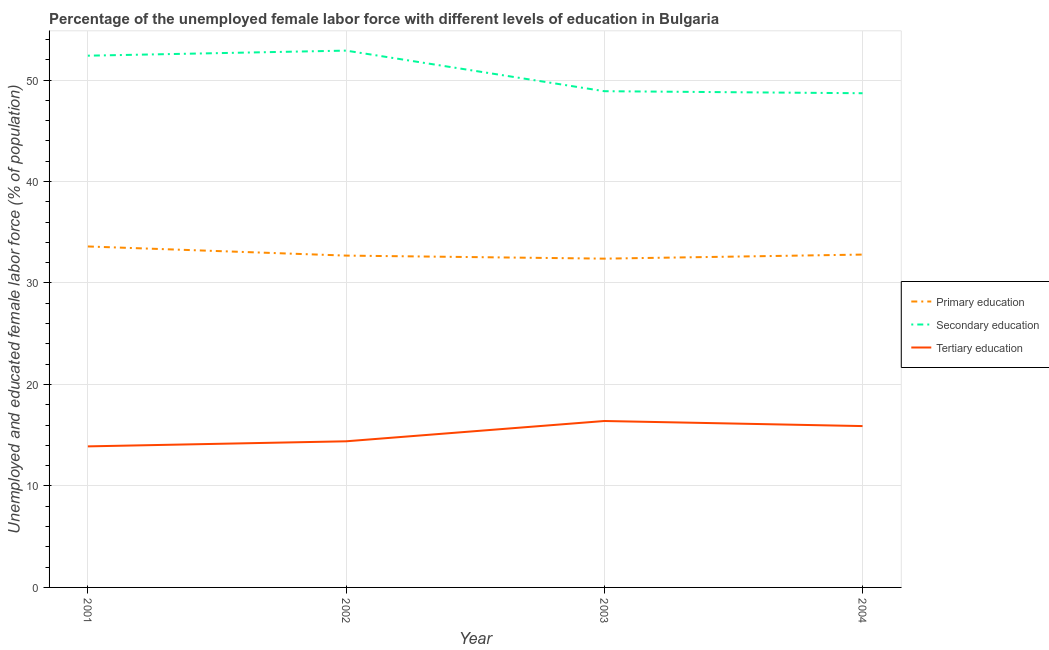How many different coloured lines are there?
Ensure brevity in your answer.  3. What is the percentage of female labor force who received tertiary education in 2002?
Make the answer very short. 14.4. Across all years, what is the maximum percentage of female labor force who received primary education?
Your answer should be very brief. 33.6. Across all years, what is the minimum percentage of female labor force who received secondary education?
Your answer should be compact. 48.7. In which year was the percentage of female labor force who received tertiary education maximum?
Offer a terse response. 2003. In which year was the percentage of female labor force who received tertiary education minimum?
Provide a succinct answer. 2001. What is the total percentage of female labor force who received secondary education in the graph?
Give a very brief answer. 202.9. What is the difference between the percentage of female labor force who received primary education in 2002 and that in 2003?
Provide a short and direct response. 0.3. What is the difference between the percentage of female labor force who received secondary education in 2001 and the percentage of female labor force who received primary education in 2002?
Offer a terse response. 19.7. What is the average percentage of female labor force who received tertiary education per year?
Keep it short and to the point. 15.15. In the year 2004, what is the difference between the percentage of female labor force who received secondary education and percentage of female labor force who received tertiary education?
Provide a succinct answer. 32.8. What is the ratio of the percentage of female labor force who received primary education in 2001 to that in 2003?
Keep it short and to the point. 1.04. What is the difference between the highest and the second highest percentage of female labor force who received secondary education?
Offer a very short reply. 0.5. What is the difference between the highest and the lowest percentage of female labor force who received secondary education?
Provide a short and direct response. 4.2. In how many years, is the percentage of female labor force who received primary education greater than the average percentage of female labor force who received primary education taken over all years?
Give a very brief answer. 1. Is the sum of the percentage of female labor force who received primary education in 2001 and 2004 greater than the maximum percentage of female labor force who received secondary education across all years?
Provide a succinct answer. Yes. Is it the case that in every year, the sum of the percentage of female labor force who received primary education and percentage of female labor force who received secondary education is greater than the percentage of female labor force who received tertiary education?
Provide a short and direct response. Yes. Does the percentage of female labor force who received secondary education monotonically increase over the years?
Provide a short and direct response. No. Is the percentage of female labor force who received tertiary education strictly less than the percentage of female labor force who received secondary education over the years?
Provide a short and direct response. Yes. How many lines are there?
Keep it short and to the point. 3. What is the difference between two consecutive major ticks on the Y-axis?
Provide a succinct answer. 10. Are the values on the major ticks of Y-axis written in scientific E-notation?
Provide a succinct answer. No. Does the graph contain grids?
Your response must be concise. Yes. Where does the legend appear in the graph?
Your answer should be very brief. Center right. What is the title of the graph?
Provide a short and direct response. Percentage of the unemployed female labor force with different levels of education in Bulgaria. What is the label or title of the Y-axis?
Make the answer very short. Unemployed and educated female labor force (% of population). What is the Unemployed and educated female labor force (% of population) in Primary education in 2001?
Offer a terse response. 33.6. What is the Unemployed and educated female labor force (% of population) of Secondary education in 2001?
Provide a short and direct response. 52.4. What is the Unemployed and educated female labor force (% of population) of Tertiary education in 2001?
Offer a terse response. 13.9. What is the Unemployed and educated female labor force (% of population) in Primary education in 2002?
Offer a very short reply. 32.7. What is the Unemployed and educated female labor force (% of population) of Secondary education in 2002?
Provide a succinct answer. 52.9. What is the Unemployed and educated female labor force (% of population) of Tertiary education in 2002?
Make the answer very short. 14.4. What is the Unemployed and educated female labor force (% of population) of Primary education in 2003?
Ensure brevity in your answer.  32.4. What is the Unemployed and educated female labor force (% of population) of Secondary education in 2003?
Your answer should be very brief. 48.9. What is the Unemployed and educated female labor force (% of population) in Tertiary education in 2003?
Your answer should be compact. 16.4. What is the Unemployed and educated female labor force (% of population) in Primary education in 2004?
Offer a very short reply. 32.8. What is the Unemployed and educated female labor force (% of population) in Secondary education in 2004?
Offer a terse response. 48.7. What is the Unemployed and educated female labor force (% of population) in Tertiary education in 2004?
Give a very brief answer. 15.9. Across all years, what is the maximum Unemployed and educated female labor force (% of population) in Primary education?
Offer a terse response. 33.6. Across all years, what is the maximum Unemployed and educated female labor force (% of population) in Secondary education?
Provide a succinct answer. 52.9. Across all years, what is the maximum Unemployed and educated female labor force (% of population) of Tertiary education?
Keep it short and to the point. 16.4. Across all years, what is the minimum Unemployed and educated female labor force (% of population) of Primary education?
Keep it short and to the point. 32.4. Across all years, what is the minimum Unemployed and educated female labor force (% of population) in Secondary education?
Offer a terse response. 48.7. Across all years, what is the minimum Unemployed and educated female labor force (% of population) in Tertiary education?
Make the answer very short. 13.9. What is the total Unemployed and educated female labor force (% of population) in Primary education in the graph?
Ensure brevity in your answer.  131.5. What is the total Unemployed and educated female labor force (% of population) of Secondary education in the graph?
Provide a succinct answer. 202.9. What is the total Unemployed and educated female labor force (% of population) of Tertiary education in the graph?
Ensure brevity in your answer.  60.6. What is the difference between the Unemployed and educated female labor force (% of population) in Secondary education in 2001 and that in 2002?
Your answer should be compact. -0.5. What is the difference between the Unemployed and educated female labor force (% of population) of Tertiary education in 2001 and that in 2002?
Offer a very short reply. -0.5. What is the difference between the Unemployed and educated female labor force (% of population) in Primary education in 2001 and that in 2003?
Your answer should be compact. 1.2. What is the difference between the Unemployed and educated female labor force (% of population) of Primary education in 2002 and that in 2004?
Keep it short and to the point. -0.1. What is the difference between the Unemployed and educated female labor force (% of population) in Tertiary education in 2003 and that in 2004?
Offer a terse response. 0.5. What is the difference between the Unemployed and educated female labor force (% of population) in Primary education in 2001 and the Unemployed and educated female labor force (% of population) in Secondary education in 2002?
Make the answer very short. -19.3. What is the difference between the Unemployed and educated female labor force (% of population) in Secondary education in 2001 and the Unemployed and educated female labor force (% of population) in Tertiary education in 2002?
Offer a terse response. 38. What is the difference between the Unemployed and educated female labor force (% of population) of Primary education in 2001 and the Unemployed and educated female labor force (% of population) of Secondary education in 2003?
Provide a succinct answer. -15.3. What is the difference between the Unemployed and educated female labor force (% of population) of Primary education in 2001 and the Unemployed and educated female labor force (% of population) of Secondary education in 2004?
Make the answer very short. -15.1. What is the difference between the Unemployed and educated female labor force (% of population) of Primary education in 2001 and the Unemployed and educated female labor force (% of population) of Tertiary education in 2004?
Offer a very short reply. 17.7. What is the difference between the Unemployed and educated female labor force (% of population) of Secondary education in 2001 and the Unemployed and educated female labor force (% of population) of Tertiary education in 2004?
Offer a very short reply. 36.5. What is the difference between the Unemployed and educated female labor force (% of population) in Primary education in 2002 and the Unemployed and educated female labor force (% of population) in Secondary education in 2003?
Keep it short and to the point. -16.2. What is the difference between the Unemployed and educated female labor force (% of population) in Primary education in 2002 and the Unemployed and educated female labor force (% of population) in Tertiary education in 2003?
Offer a terse response. 16.3. What is the difference between the Unemployed and educated female labor force (% of population) in Secondary education in 2002 and the Unemployed and educated female labor force (% of population) in Tertiary education in 2003?
Provide a short and direct response. 36.5. What is the difference between the Unemployed and educated female labor force (% of population) in Primary education in 2003 and the Unemployed and educated female labor force (% of population) in Secondary education in 2004?
Ensure brevity in your answer.  -16.3. What is the difference between the Unemployed and educated female labor force (% of population) of Secondary education in 2003 and the Unemployed and educated female labor force (% of population) of Tertiary education in 2004?
Your response must be concise. 33. What is the average Unemployed and educated female labor force (% of population) in Primary education per year?
Ensure brevity in your answer.  32.88. What is the average Unemployed and educated female labor force (% of population) in Secondary education per year?
Offer a terse response. 50.73. What is the average Unemployed and educated female labor force (% of population) in Tertiary education per year?
Offer a very short reply. 15.15. In the year 2001, what is the difference between the Unemployed and educated female labor force (% of population) in Primary education and Unemployed and educated female labor force (% of population) in Secondary education?
Keep it short and to the point. -18.8. In the year 2001, what is the difference between the Unemployed and educated female labor force (% of population) of Secondary education and Unemployed and educated female labor force (% of population) of Tertiary education?
Provide a short and direct response. 38.5. In the year 2002, what is the difference between the Unemployed and educated female labor force (% of population) in Primary education and Unemployed and educated female labor force (% of population) in Secondary education?
Offer a terse response. -20.2. In the year 2002, what is the difference between the Unemployed and educated female labor force (% of population) in Primary education and Unemployed and educated female labor force (% of population) in Tertiary education?
Provide a short and direct response. 18.3. In the year 2002, what is the difference between the Unemployed and educated female labor force (% of population) of Secondary education and Unemployed and educated female labor force (% of population) of Tertiary education?
Offer a very short reply. 38.5. In the year 2003, what is the difference between the Unemployed and educated female labor force (% of population) of Primary education and Unemployed and educated female labor force (% of population) of Secondary education?
Offer a very short reply. -16.5. In the year 2003, what is the difference between the Unemployed and educated female labor force (% of population) in Primary education and Unemployed and educated female labor force (% of population) in Tertiary education?
Your answer should be very brief. 16. In the year 2003, what is the difference between the Unemployed and educated female labor force (% of population) of Secondary education and Unemployed and educated female labor force (% of population) of Tertiary education?
Make the answer very short. 32.5. In the year 2004, what is the difference between the Unemployed and educated female labor force (% of population) in Primary education and Unemployed and educated female labor force (% of population) in Secondary education?
Your answer should be compact. -15.9. In the year 2004, what is the difference between the Unemployed and educated female labor force (% of population) in Primary education and Unemployed and educated female labor force (% of population) in Tertiary education?
Offer a very short reply. 16.9. In the year 2004, what is the difference between the Unemployed and educated female labor force (% of population) in Secondary education and Unemployed and educated female labor force (% of population) in Tertiary education?
Offer a very short reply. 32.8. What is the ratio of the Unemployed and educated female labor force (% of population) in Primary education in 2001 to that in 2002?
Offer a terse response. 1.03. What is the ratio of the Unemployed and educated female labor force (% of population) in Secondary education in 2001 to that in 2002?
Your answer should be compact. 0.99. What is the ratio of the Unemployed and educated female labor force (% of population) in Tertiary education in 2001 to that in 2002?
Give a very brief answer. 0.97. What is the ratio of the Unemployed and educated female labor force (% of population) in Primary education in 2001 to that in 2003?
Keep it short and to the point. 1.04. What is the ratio of the Unemployed and educated female labor force (% of population) in Secondary education in 2001 to that in 2003?
Provide a succinct answer. 1.07. What is the ratio of the Unemployed and educated female labor force (% of population) in Tertiary education in 2001 to that in 2003?
Keep it short and to the point. 0.85. What is the ratio of the Unemployed and educated female labor force (% of population) of Primary education in 2001 to that in 2004?
Your answer should be very brief. 1.02. What is the ratio of the Unemployed and educated female labor force (% of population) of Secondary education in 2001 to that in 2004?
Ensure brevity in your answer.  1.08. What is the ratio of the Unemployed and educated female labor force (% of population) of Tertiary education in 2001 to that in 2004?
Provide a succinct answer. 0.87. What is the ratio of the Unemployed and educated female labor force (% of population) of Primary education in 2002 to that in 2003?
Make the answer very short. 1.01. What is the ratio of the Unemployed and educated female labor force (% of population) in Secondary education in 2002 to that in 2003?
Give a very brief answer. 1.08. What is the ratio of the Unemployed and educated female labor force (% of population) of Tertiary education in 2002 to that in 2003?
Offer a very short reply. 0.88. What is the ratio of the Unemployed and educated female labor force (% of population) in Secondary education in 2002 to that in 2004?
Keep it short and to the point. 1.09. What is the ratio of the Unemployed and educated female labor force (% of population) in Tertiary education in 2002 to that in 2004?
Your response must be concise. 0.91. What is the ratio of the Unemployed and educated female labor force (% of population) of Primary education in 2003 to that in 2004?
Make the answer very short. 0.99. What is the ratio of the Unemployed and educated female labor force (% of population) of Secondary education in 2003 to that in 2004?
Provide a succinct answer. 1. What is the ratio of the Unemployed and educated female labor force (% of population) of Tertiary education in 2003 to that in 2004?
Provide a succinct answer. 1.03. What is the difference between the highest and the second highest Unemployed and educated female labor force (% of population) of Primary education?
Make the answer very short. 0.8. 